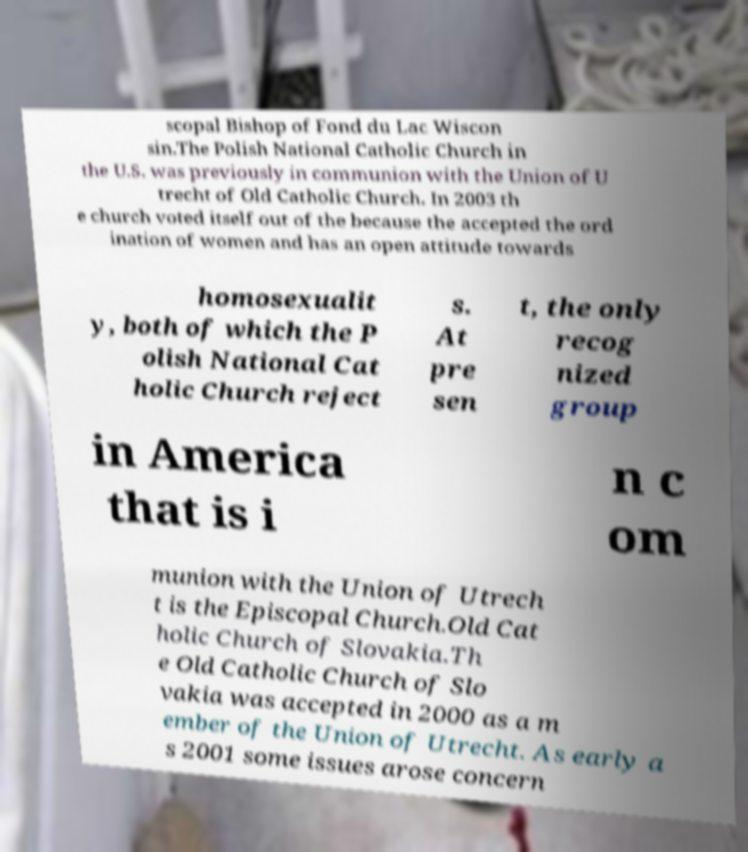Could you extract and type out the text from this image? scopal Bishop of Fond du Lac Wiscon sin.The Polish National Catholic Church in the U.S. was previously in communion with the Union of U trecht of Old Catholic Church. In 2003 th e church voted itself out of the because the accepted the ord ination of women and has an open attitude towards homosexualit y, both of which the P olish National Cat holic Church reject s. At pre sen t, the only recog nized group in America that is i n c om munion with the Union of Utrech t is the Episcopal Church.Old Cat holic Church of Slovakia.Th e Old Catholic Church of Slo vakia was accepted in 2000 as a m ember of the Union of Utrecht. As early a s 2001 some issues arose concern 